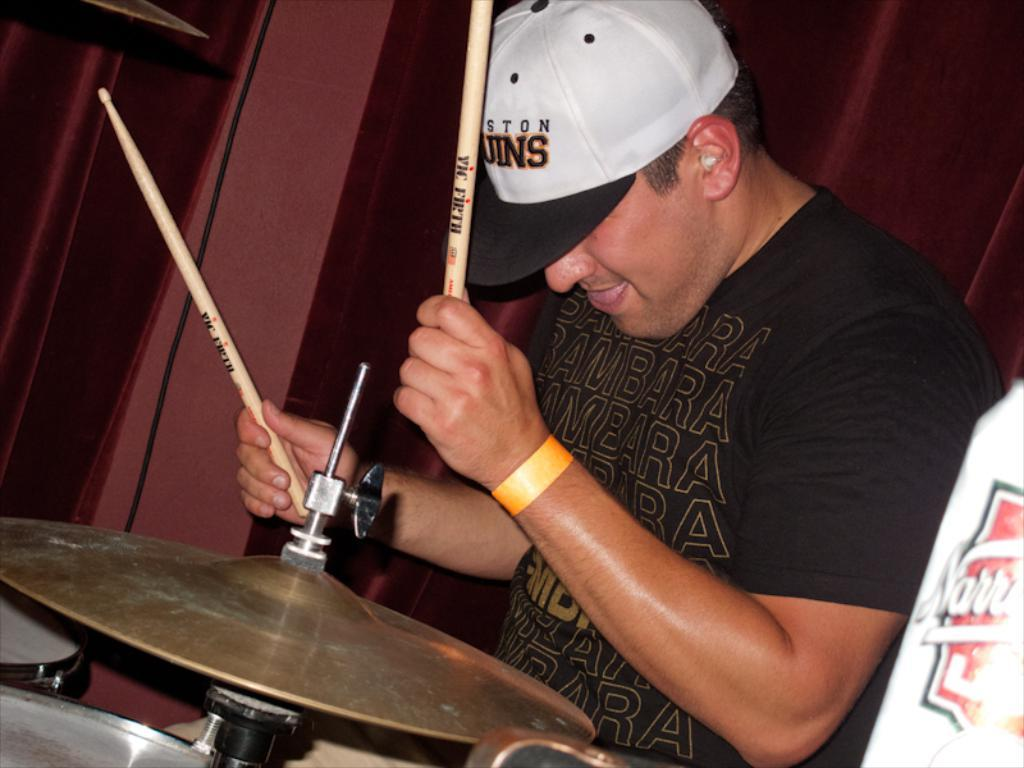<image>
Create a compact narrative representing the image presented. A man is playing a drum set and wearing a had that says Houston Bruins. 